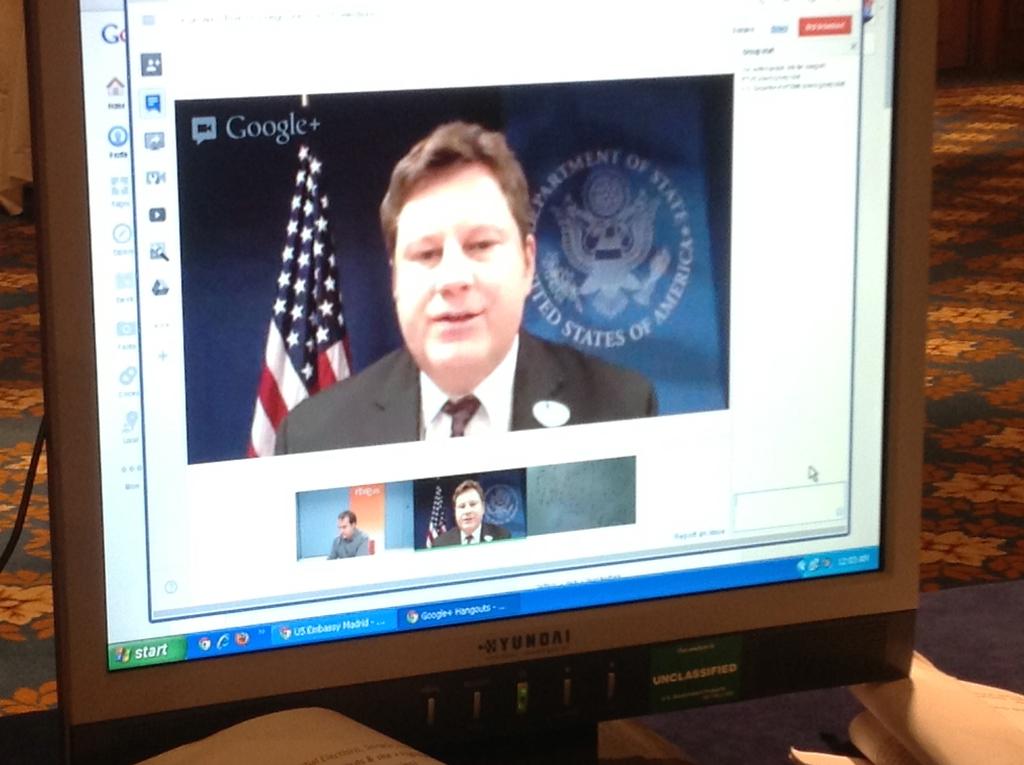What platform is the video from?
Provide a succinct answer. Google. 